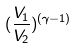Convert formula to latex. <formula><loc_0><loc_0><loc_500><loc_500>( \frac { V _ { 1 } } { V _ { 2 } } ) ^ { ( \gamma - 1 ) }</formula> 